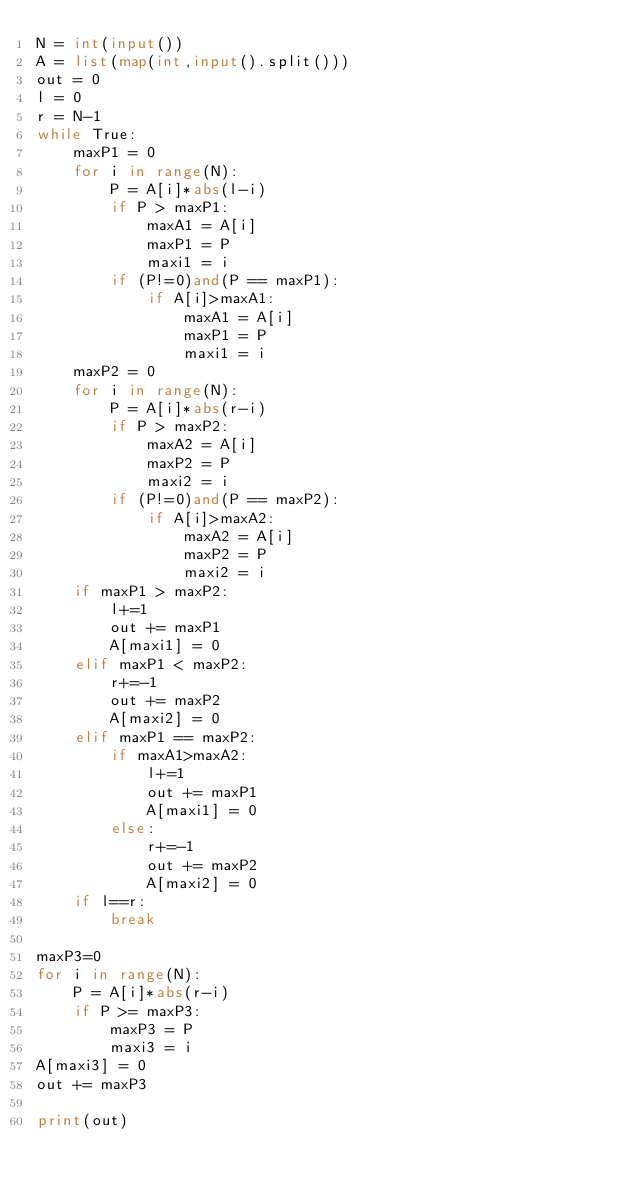Convert code to text. <code><loc_0><loc_0><loc_500><loc_500><_Python_>N = int(input())
A = list(map(int,input().split()))
out = 0
l = 0
r = N-1
while True:
    maxP1 = 0
    for i in range(N):
        P = A[i]*abs(l-i)
        if P > maxP1:
            maxA1 = A[i]
            maxP1 = P
            maxi1 = i
        if (P!=0)and(P == maxP1):
            if A[i]>maxA1:
                maxA1 = A[i]
                maxP1 = P
                maxi1 = i
    maxP2 = 0
    for i in range(N):
        P = A[i]*abs(r-i)
        if P > maxP2:
            maxA2 = A[i]
            maxP2 = P
            maxi2 = i
        if (P!=0)and(P == maxP2):
            if A[i]>maxA2:
                maxA2 = A[i]
                maxP2 = P
                maxi2 = i
    if maxP1 > maxP2:
        l+=1
        out += maxP1
        A[maxi1] = 0
    elif maxP1 < maxP2:
        r+=-1
        out += maxP2
        A[maxi2] = 0
    elif maxP1 == maxP2:
        if maxA1>maxA2:
            l+=1
            out += maxP1
            A[maxi1] = 0
        else:
            r+=-1
            out += maxP2
            A[maxi2] = 0
    if l==r:
        break

maxP3=0
for i in range(N):
    P = A[i]*abs(r-i)
    if P >= maxP3:
        maxP3 = P
        maxi3 = i
A[maxi3] = 0
out += maxP3

print(out)</code> 